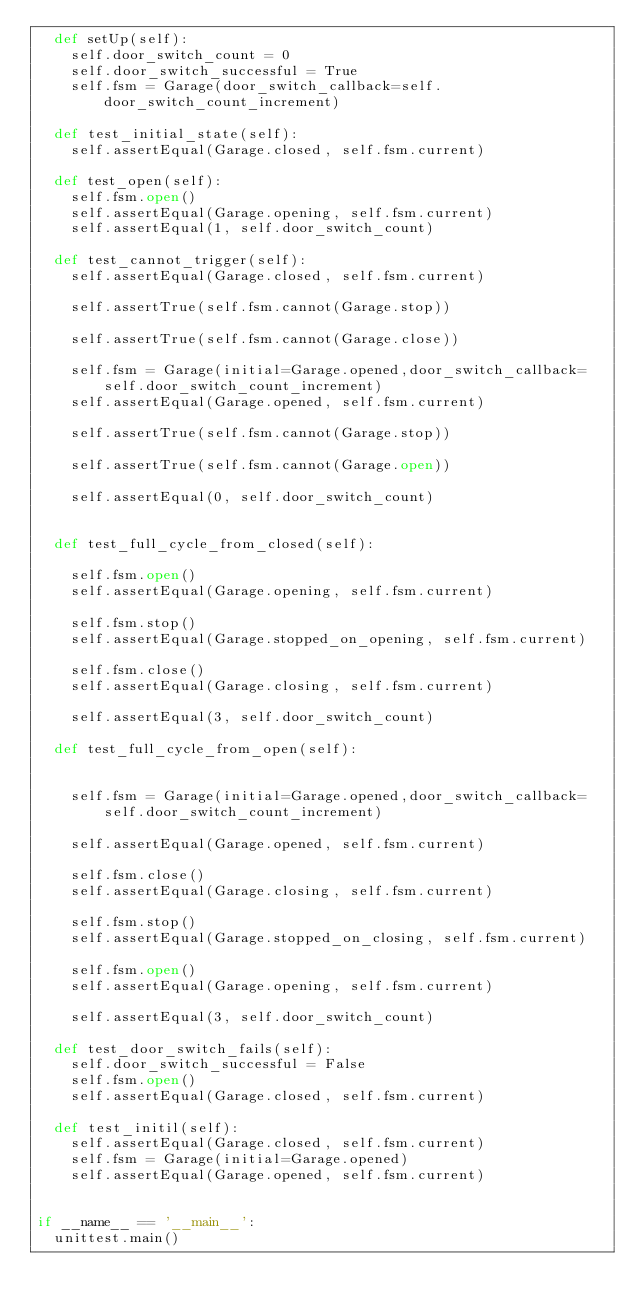Convert code to text. <code><loc_0><loc_0><loc_500><loc_500><_Python_>	def setUp(self):
		self.door_switch_count = 0
		self.door_switch_successful = True
		self.fsm = Garage(door_switch_callback=self.door_switch_count_increment)

	def test_initial_state(self):
		self.assertEqual(Garage.closed, self.fsm.current)

	def test_open(self):
		self.fsm.open()
		self.assertEqual(Garage.opening, self.fsm.current)		
		self.assertEqual(1, self.door_switch_count)
		
	def test_cannot_trigger(self):
		self.assertEqual(Garage.closed, self.fsm.current)
	
		self.assertTrue(self.fsm.cannot(Garage.stop))
		
		self.assertTrue(self.fsm.cannot(Garage.close))

		self.fsm = Garage(initial=Garage.opened,door_switch_callback=self.door_switch_count_increment)
		self.assertEqual(Garage.opened, self.fsm.current)
		
		self.assertTrue(self.fsm.cannot(Garage.stop))
		
		self.assertTrue(self.fsm.cannot(Garage.open))
		
		self.assertEqual(0, self.door_switch_count)
		

	def test_full_cycle_from_closed(self):
		
		self.fsm.open()
		self.assertEqual(Garage.opening, self.fsm.current)
		
		self.fsm.stop()
		self.assertEqual(Garage.stopped_on_opening, self.fsm.current)
		
		self.fsm.close()
		self.assertEqual(Garage.closing, self.fsm.current)
		
		self.assertEqual(3, self.door_switch_count)

	def test_full_cycle_from_open(self):
		

		self.fsm = Garage(initial=Garage.opened,door_switch_callback=self.door_switch_count_increment)

		self.assertEqual(Garage.opened, self.fsm.current)
		
		self.fsm.close()
		self.assertEqual(Garage.closing, self.fsm.current)
		
		self.fsm.stop()
		self.assertEqual(Garage.stopped_on_closing, self.fsm.current)
		
		self.fsm.open()
		self.assertEqual(Garage.opening, self.fsm.current)
		
		self.assertEqual(3, self.door_switch_count)
			
	def test_door_switch_fails(self):
		self.door_switch_successful = False
		self.fsm.open()
		self.assertEqual(Garage.closed, self.fsm.current)
	
	def test_initil(self):
		self.assertEqual(Garage.closed, self.fsm.current)
		self.fsm = Garage(initial=Garage.opened)
		self.assertEqual(Garage.opened, self.fsm.current)

	
if __name__ == '__main__':
	unittest.main()
	
</code> 